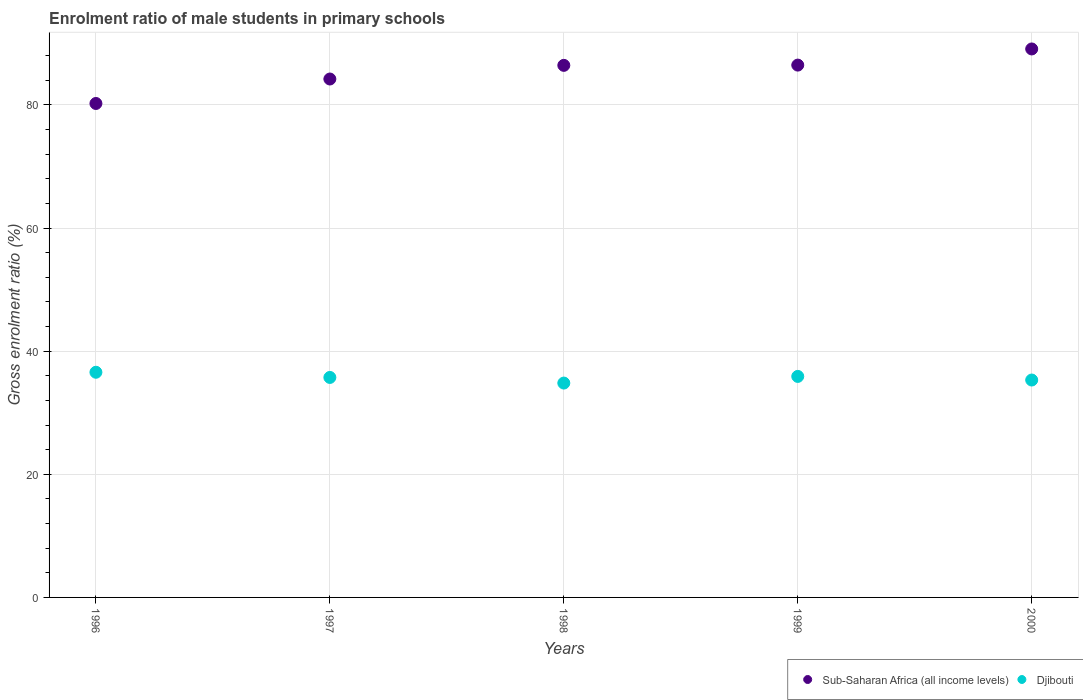How many different coloured dotlines are there?
Ensure brevity in your answer.  2. What is the enrolment ratio of male students in primary schools in Djibouti in 2000?
Keep it short and to the point. 35.32. Across all years, what is the maximum enrolment ratio of male students in primary schools in Sub-Saharan Africa (all income levels)?
Provide a short and direct response. 89.1. Across all years, what is the minimum enrolment ratio of male students in primary schools in Djibouti?
Give a very brief answer. 34.82. In which year was the enrolment ratio of male students in primary schools in Sub-Saharan Africa (all income levels) maximum?
Offer a terse response. 2000. In which year was the enrolment ratio of male students in primary schools in Sub-Saharan Africa (all income levels) minimum?
Your answer should be compact. 1996. What is the total enrolment ratio of male students in primary schools in Sub-Saharan Africa (all income levels) in the graph?
Give a very brief answer. 426.45. What is the difference between the enrolment ratio of male students in primary schools in Sub-Saharan Africa (all income levels) in 1997 and that in 2000?
Your answer should be compact. -4.88. What is the difference between the enrolment ratio of male students in primary schools in Sub-Saharan Africa (all income levels) in 1999 and the enrolment ratio of male students in primary schools in Djibouti in 1996?
Offer a terse response. 49.9. What is the average enrolment ratio of male students in primary schools in Djibouti per year?
Offer a very short reply. 35.67. In the year 1999, what is the difference between the enrolment ratio of male students in primary schools in Djibouti and enrolment ratio of male students in primary schools in Sub-Saharan Africa (all income levels)?
Ensure brevity in your answer.  -50.57. In how many years, is the enrolment ratio of male students in primary schools in Djibouti greater than 80 %?
Provide a succinct answer. 0. What is the ratio of the enrolment ratio of male students in primary schools in Sub-Saharan Africa (all income levels) in 1996 to that in 2000?
Offer a very short reply. 0.9. Is the enrolment ratio of male students in primary schools in Djibouti in 1998 less than that in 1999?
Make the answer very short. Yes. Is the difference between the enrolment ratio of male students in primary schools in Djibouti in 1997 and 2000 greater than the difference between the enrolment ratio of male students in primary schools in Sub-Saharan Africa (all income levels) in 1997 and 2000?
Offer a terse response. Yes. What is the difference between the highest and the second highest enrolment ratio of male students in primary schools in Sub-Saharan Africa (all income levels)?
Make the answer very short. 2.62. What is the difference between the highest and the lowest enrolment ratio of male students in primary schools in Sub-Saharan Africa (all income levels)?
Provide a short and direct response. 8.86. Does the enrolment ratio of male students in primary schools in Sub-Saharan Africa (all income levels) monotonically increase over the years?
Offer a terse response. Yes. Is the enrolment ratio of male students in primary schools in Djibouti strictly less than the enrolment ratio of male students in primary schools in Sub-Saharan Africa (all income levels) over the years?
Provide a short and direct response. Yes. How many years are there in the graph?
Provide a succinct answer. 5. Does the graph contain any zero values?
Provide a succinct answer. No. Does the graph contain grids?
Offer a terse response. Yes. Where does the legend appear in the graph?
Ensure brevity in your answer.  Bottom right. How are the legend labels stacked?
Provide a succinct answer. Horizontal. What is the title of the graph?
Your answer should be very brief. Enrolment ratio of male students in primary schools. What is the label or title of the X-axis?
Give a very brief answer. Years. What is the label or title of the Y-axis?
Offer a very short reply. Gross enrolment ratio (%). What is the Gross enrolment ratio (%) of Sub-Saharan Africa (all income levels) in 1996?
Provide a succinct answer. 80.24. What is the Gross enrolment ratio (%) in Djibouti in 1996?
Give a very brief answer. 36.58. What is the Gross enrolment ratio (%) in Sub-Saharan Africa (all income levels) in 1997?
Your response must be concise. 84.21. What is the Gross enrolment ratio (%) of Djibouti in 1997?
Make the answer very short. 35.74. What is the Gross enrolment ratio (%) of Sub-Saharan Africa (all income levels) in 1998?
Ensure brevity in your answer.  86.43. What is the Gross enrolment ratio (%) in Djibouti in 1998?
Keep it short and to the point. 34.82. What is the Gross enrolment ratio (%) of Sub-Saharan Africa (all income levels) in 1999?
Your answer should be very brief. 86.47. What is the Gross enrolment ratio (%) in Djibouti in 1999?
Your answer should be very brief. 35.9. What is the Gross enrolment ratio (%) of Sub-Saharan Africa (all income levels) in 2000?
Provide a succinct answer. 89.1. What is the Gross enrolment ratio (%) in Djibouti in 2000?
Provide a short and direct response. 35.32. Across all years, what is the maximum Gross enrolment ratio (%) of Sub-Saharan Africa (all income levels)?
Keep it short and to the point. 89.1. Across all years, what is the maximum Gross enrolment ratio (%) of Djibouti?
Provide a short and direct response. 36.58. Across all years, what is the minimum Gross enrolment ratio (%) of Sub-Saharan Africa (all income levels)?
Make the answer very short. 80.24. Across all years, what is the minimum Gross enrolment ratio (%) in Djibouti?
Provide a succinct answer. 34.82. What is the total Gross enrolment ratio (%) of Sub-Saharan Africa (all income levels) in the graph?
Make the answer very short. 426.45. What is the total Gross enrolment ratio (%) of Djibouti in the graph?
Offer a very short reply. 178.35. What is the difference between the Gross enrolment ratio (%) of Sub-Saharan Africa (all income levels) in 1996 and that in 1997?
Your answer should be very brief. -3.97. What is the difference between the Gross enrolment ratio (%) in Djibouti in 1996 and that in 1997?
Provide a short and direct response. 0.84. What is the difference between the Gross enrolment ratio (%) of Sub-Saharan Africa (all income levels) in 1996 and that in 1998?
Make the answer very short. -6.19. What is the difference between the Gross enrolment ratio (%) in Djibouti in 1996 and that in 1998?
Your answer should be very brief. 1.76. What is the difference between the Gross enrolment ratio (%) in Sub-Saharan Africa (all income levels) in 1996 and that in 1999?
Your answer should be very brief. -6.23. What is the difference between the Gross enrolment ratio (%) in Djibouti in 1996 and that in 1999?
Your answer should be very brief. 0.67. What is the difference between the Gross enrolment ratio (%) of Sub-Saharan Africa (all income levels) in 1996 and that in 2000?
Offer a very short reply. -8.86. What is the difference between the Gross enrolment ratio (%) of Djibouti in 1996 and that in 2000?
Your response must be concise. 1.26. What is the difference between the Gross enrolment ratio (%) in Sub-Saharan Africa (all income levels) in 1997 and that in 1998?
Your answer should be very brief. -2.22. What is the difference between the Gross enrolment ratio (%) of Djibouti in 1997 and that in 1998?
Your response must be concise. 0.91. What is the difference between the Gross enrolment ratio (%) of Sub-Saharan Africa (all income levels) in 1997 and that in 1999?
Offer a terse response. -2.26. What is the difference between the Gross enrolment ratio (%) in Djibouti in 1997 and that in 1999?
Your response must be concise. -0.17. What is the difference between the Gross enrolment ratio (%) in Sub-Saharan Africa (all income levels) in 1997 and that in 2000?
Your answer should be very brief. -4.88. What is the difference between the Gross enrolment ratio (%) in Djibouti in 1997 and that in 2000?
Your response must be concise. 0.42. What is the difference between the Gross enrolment ratio (%) in Sub-Saharan Africa (all income levels) in 1998 and that in 1999?
Your answer should be compact. -0.04. What is the difference between the Gross enrolment ratio (%) in Djibouti in 1998 and that in 1999?
Provide a succinct answer. -1.08. What is the difference between the Gross enrolment ratio (%) in Sub-Saharan Africa (all income levels) in 1998 and that in 2000?
Give a very brief answer. -2.66. What is the difference between the Gross enrolment ratio (%) of Djibouti in 1998 and that in 2000?
Offer a very short reply. -0.49. What is the difference between the Gross enrolment ratio (%) of Sub-Saharan Africa (all income levels) in 1999 and that in 2000?
Ensure brevity in your answer.  -2.62. What is the difference between the Gross enrolment ratio (%) in Djibouti in 1999 and that in 2000?
Keep it short and to the point. 0.59. What is the difference between the Gross enrolment ratio (%) of Sub-Saharan Africa (all income levels) in 1996 and the Gross enrolment ratio (%) of Djibouti in 1997?
Offer a very short reply. 44.5. What is the difference between the Gross enrolment ratio (%) in Sub-Saharan Africa (all income levels) in 1996 and the Gross enrolment ratio (%) in Djibouti in 1998?
Your answer should be very brief. 45.42. What is the difference between the Gross enrolment ratio (%) of Sub-Saharan Africa (all income levels) in 1996 and the Gross enrolment ratio (%) of Djibouti in 1999?
Offer a very short reply. 44.34. What is the difference between the Gross enrolment ratio (%) of Sub-Saharan Africa (all income levels) in 1996 and the Gross enrolment ratio (%) of Djibouti in 2000?
Your response must be concise. 44.92. What is the difference between the Gross enrolment ratio (%) in Sub-Saharan Africa (all income levels) in 1997 and the Gross enrolment ratio (%) in Djibouti in 1998?
Your answer should be compact. 49.39. What is the difference between the Gross enrolment ratio (%) of Sub-Saharan Africa (all income levels) in 1997 and the Gross enrolment ratio (%) of Djibouti in 1999?
Give a very brief answer. 48.31. What is the difference between the Gross enrolment ratio (%) of Sub-Saharan Africa (all income levels) in 1997 and the Gross enrolment ratio (%) of Djibouti in 2000?
Your answer should be very brief. 48.9. What is the difference between the Gross enrolment ratio (%) in Sub-Saharan Africa (all income levels) in 1998 and the Gross enrolment ratio (%) in Djibouti in 1999?
Provide a succinct answer. 50.53. What is the difference between the Gross enrolment ratio (%) of Sub-Saharan Africa (all income levels) in 1998 and the Gross enrolment ratio (%) of Djibouti in 2000?
Offer a terse response. 51.12. What is the difference between the Gross enrolment ratio (%) of Sub-Saharan Africa (all income levels) in 1999 and the Gross enrolment ratio (%) of Djibouti in 2000?
Offer a terse response. 51.16. What is the average Gross enrolment ratio (%) of Sub-Saharan Africa (all income levels) per year?
Ensure brevity in your answer.  85.29. What is the average Gross enrolment ratio (%) in Djibouti per year?
Give a very brief answer. 35.67. In the year 1996, what is the difference between the Gross enrolment ratio (%) of Sub-Saharan Africa (all income levels) and Gross enrolment ratio (%) of Djibouti?
Your response must be concise. 43.66. In the year 1997, what is the difference between the Gross enrolment ratio (%) in Sub-Saharan Africa (all income levels) and Gross enrolment ratio (%) in Djibouti?
Provide a short and direct response. 48.48. In the year 1998, what is the difference between the Gross enrolment ratio (%) in Sub-Saharan Africa (all income levels) and Gross enrolment ratio (%) in Djibouti?
Ensure brevity in your answer.  51.61. In the year 1999, what is the difference between the Gross enrolment ratio (%) in Sub-Saharan Africa (all income levels) and Gross enrolment ratio (%) in Djibouti?
Make the answer very short. 50.57. In the year 2000, what is the difference between the Gross enrolment ratio (%) in Sub-Saharan Africa (all income levels) and Gross enrolment ratio (%) in Djibouti?
Offer a terse response. 53.78. What is the ratio of the Gross enrolment ratio (%) in Sub-Saharan Africa (all income levels) in 1996 to that in 1997?
Offer a very short reply. 0.95. What is the ratio of the Gross enrolment ratio (%) in Djibouti in 1996 to that in 1997?
Make the answer very short. 1.02. What is the ratio of the Gross enrolment ratio (%) of Sub-Saharan Africa (all income levels) in 1996 to that in 1998?
Make the answer very short. 0.93. What is the ratio of the Gross enrolment ratio (%) in Djibouti in 1996 to that in 1998?
Make the answer very short. 1.05. What is the ratio of the Gross enrolment ratio (%) of Sub-Saharan Africa (all income levels) in 1996 to that in 1999?
Offer a very short reply. 0.93. What is the ratio of the Gross enrolment ratio (%) of Djibouti in 1996 to that in 1999?
Make the answer very short. 1.02. What is the ratio of the Gross enrolment ratio (%) in Sub-Saharan Africa (all income levels) in 1996 to that in 2000?
Provide a short and direct response. 0.9. What is the ratio of the Gross enrolment ratio (%) of Djibouti in 1996 to that in 2000?
Your answer should be very brief. 1.04. What is the ratio of the Gross enrolment ratio (%) of Sub-Saharan Africa (all income levels) in 1997 to that in 1998?
Give a very brief answer. 0.97. What is the ratio of the Gross enrolment ratio (%) in Djibouti in 1997 to that in 1998?
Provide a short and direct response. 1.03. What is the ratio of the Gross enrolment ratio (%) of Sub-Saharan Africa (all income levels) in 1997 to that in 1999?
Your answer should be compact. 0.97. What is the ratio of the Gross enrolment ratio (%) in Djibouti in 1997 to that in 1999?
Offer a terse response. 1. What is the ratio of the Gross enrolment ratio (%) in Sub-Saharan Africa (all income levels) in 1997 to that in 2000?
Your response must be concise. 0.95. What is the ratio of the Gross enrolment ratio (%) of Djibouti in 1997 to that in 2000?
Keep it short and to the point. 1.01. What is the ratio of the Gross enrolment ratio (%) in Sub-Saharan Africa (all income levels) in 1998 to that in 1999?
Make the answer very short. 1. What is the ratio of the Gross enrolment ratio (%) of Djibouti in 1998 to that in 1999?
Offer a terse response. 0.97. What is the ratio of the Gross enrolment ratio (%) of Sub-Saharan Africa (all income levels) in 1998 to that in 2000?
Provide a succinct answer. 0.97. What is the ratio of the Gross enrolment ratio (%) in Sub-Saharan Africa (all income levels) in 1999 to that in 2000?
Offer a terse response. 0.97. What is the ratio of the Gross enrolment ratio (%) of Djibouti in 1999 to that in 2000?
Your answer should be very brief. 1.02. What is the difference between the highest and the second highest Gross enrolment ratio (%) in Sub-Saharan Africa (all income levels)?
Make the answer very short. 2.62. What is the difference between the highest and the second highest Gross enrolment ratio (%) of Djibouti?
Keep it short and to the point. 0.67. What is the difference between the highest and the lowest Gross enrolment ratio (%) in Sub-Saharan Africa (all income levels)?
Make the answer very short. 8.86. What is the difference between the highest and the lowest Gross enrolment ratio (%) in Djibouti?
Your answer should be very brief. 1.76. 